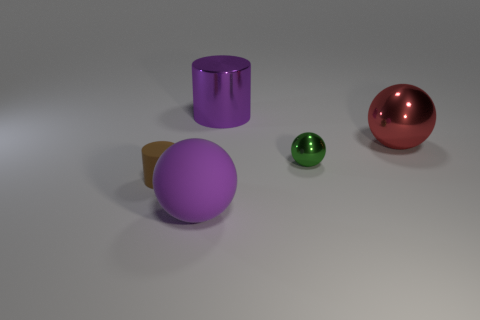Is the size of the purple metal thing the same as the purple matte thing?
Provide a succinct answer. Yes. There is another thing that is the same shape as the brown rubber thing; what is it made of?
Your answer should be very brief. Metal. What number of blue objects are either large metal cylinders or tiny spheres?
Keep it short and to the point. 0. What is the material of the small object behind the tiny brown thing?
Keep it short and to the point. Metal. Are there more purple balls than large objects?
Keep it short and to the point. No. There is a big purple thing that is on the left side of the metal cylinder; is it the same shape as the tiny matte object?
Give a very brief answer. No. What number of things are on the left side of the large red object and in front of the big shiny cylinder?
Give a very brief answer. 3. What number of other small green metallic things have the same shape as the green metallic object?
Your answer should be compact. 0. There is a big matte ball that is in front of the matte thing left of the purple sphere; what is its color?
Keep it short and to the point. Purple. Do the purple rubber object and the purple thing behind the tiny rubber object have the same shape?
Offer a terse response. No. 